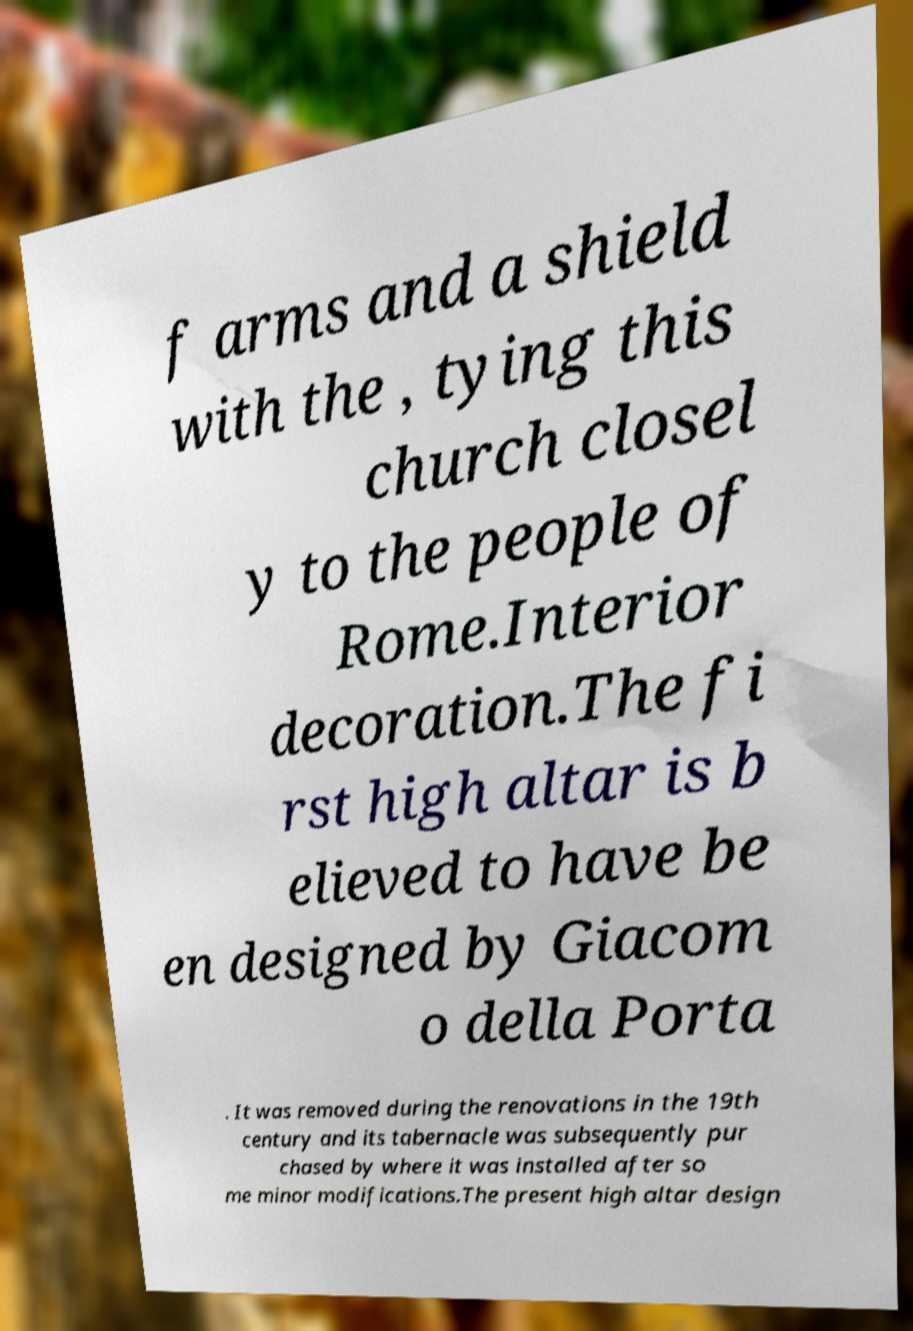For documentation purposes, I need the text within this image transcribed. Could you provide that? f arms and a shield with the , tying this church closel y to the people of Rome.Interior decoration.The fi rst high altar is b elieved to have be en designed by Giacom o della Porta . It was removed during the renovations in the 19th century and its tabernacle was subsequently pur chased by where it was installed after so me minor modifications.The present high altar design 